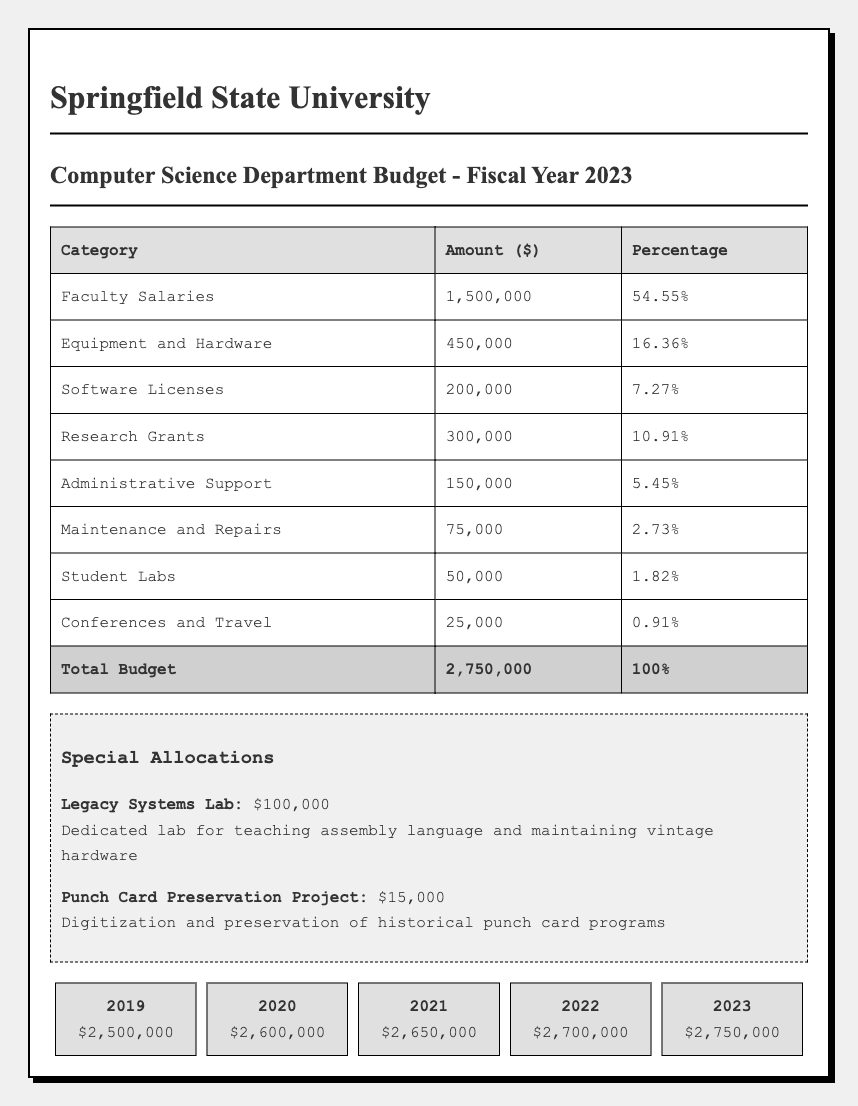What is the total budget for the Computer Science Department in fiscal year 2023? The total budget is explicitly provided in the table under the "Total Budget" row in the budget allocation section, where it states $2,750,000.
Answer: 2,750,000 What percentage of the budget is allocated to Faculty Salaries? The percentage allocated to Faculty Salaries is directly stated in the corresponding row of the table, which shows 54.55%.
Answer: 54.55% Is the amount allocated for Software Licenses greater than the amount for Conferences and Travel? From the table, Software Licenses is allocated $200,000 and Conferences and Travel is allocated $25,000. Since 200,000 > 25,000, the statement is true.
Answer: Yes What is the budget trend from 2019 to 2023? The budget has increased year-over-year, starting from $2,500,000 in 2019 to $2,750,000 in 2023, showing incremental growth each year: from 2019 to 2020 it increased by $100,000, from 2020 to 2021 by $50,000, from 2021 to 2022 by $50,000, and from 2022 to 2023 by $50,000.
Answer: Increasing How much was allocated to the Legacy Systems Lab? The amount allocated to the Legacy Systems Lab is detailed in the special allocations section, specifically identifying $100,000.
Answer: 100,000 What proportion of the total budget does Research Grants represent? Research Grants total $300,000. To find the proportion, divide it by the total budget: 300,000 / 2,750,000 = 0.1091, which can be expressed as 10.91%.
Answer: 10.91% What is the difference in budget allocation between Equipment and Hardware and Maintenance and Repairs? Equipment and Hardware is allocated $450,000 and Maintenance and Repairs is $75,000. The difference is calculated as 450,000 - 75,000 = 375,000.
Answer: 375,000 Is the combined total of Faculty Salaries and Research Grants exceeding $2,000,000? Faculty Salaries total is $1,500,000 and Research Grants total is $300,000. The sum is 1,500,000 + 300,000 = 1,800,000, which does not exceed $2,000,000.
Answer: No How does the allocation for Student Labs compare to Administrative Support? Student Labs receives $50,000 and Administrative Support receives $150,000. Since $50,000 is less than $150,000, Administrative Support has a higher allocation than Student Labs.
Answer: Administrative Support is higher 